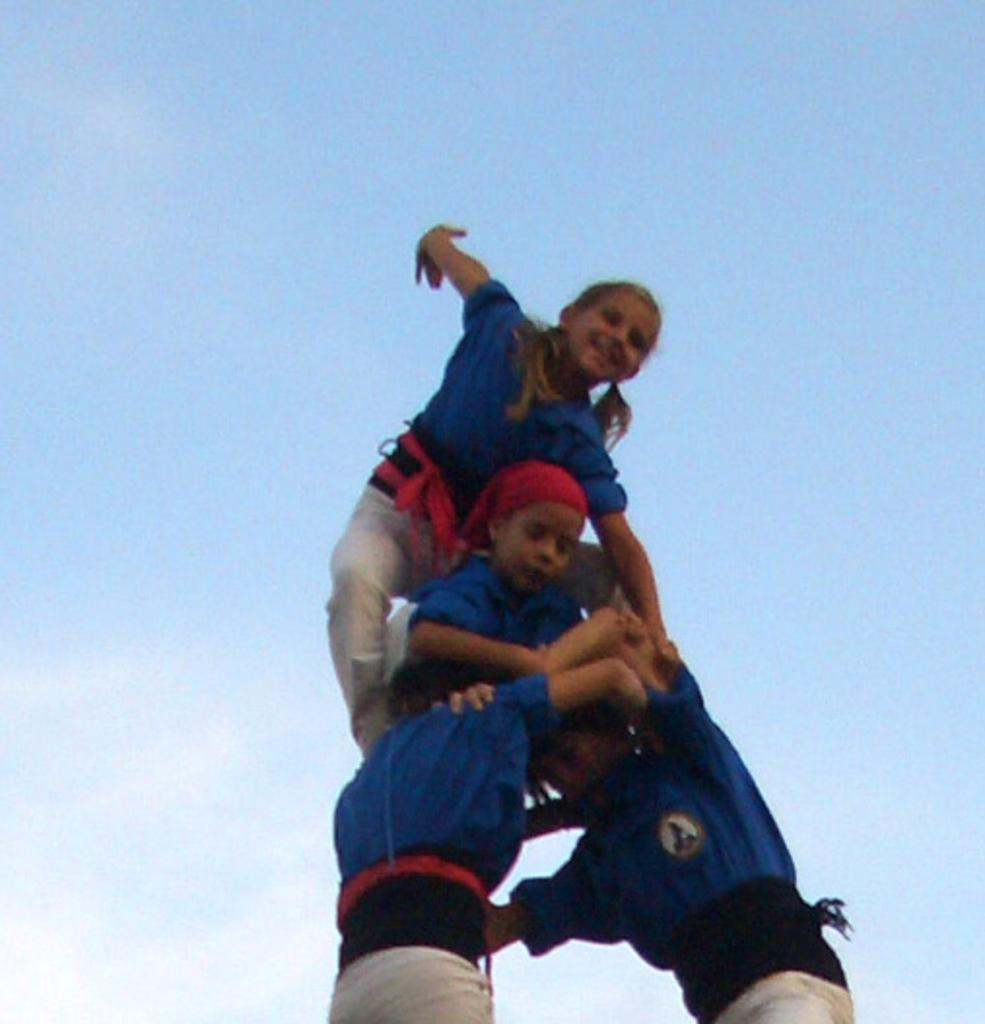How many individuals are present in the image? There are many people in the image. What is the color of the sky in the image? The sky is blue in the image. How many boxes can be seen in the image? There is no box present in the image. What type of test is being conducted in the image? There is no test being conducted in the image. 